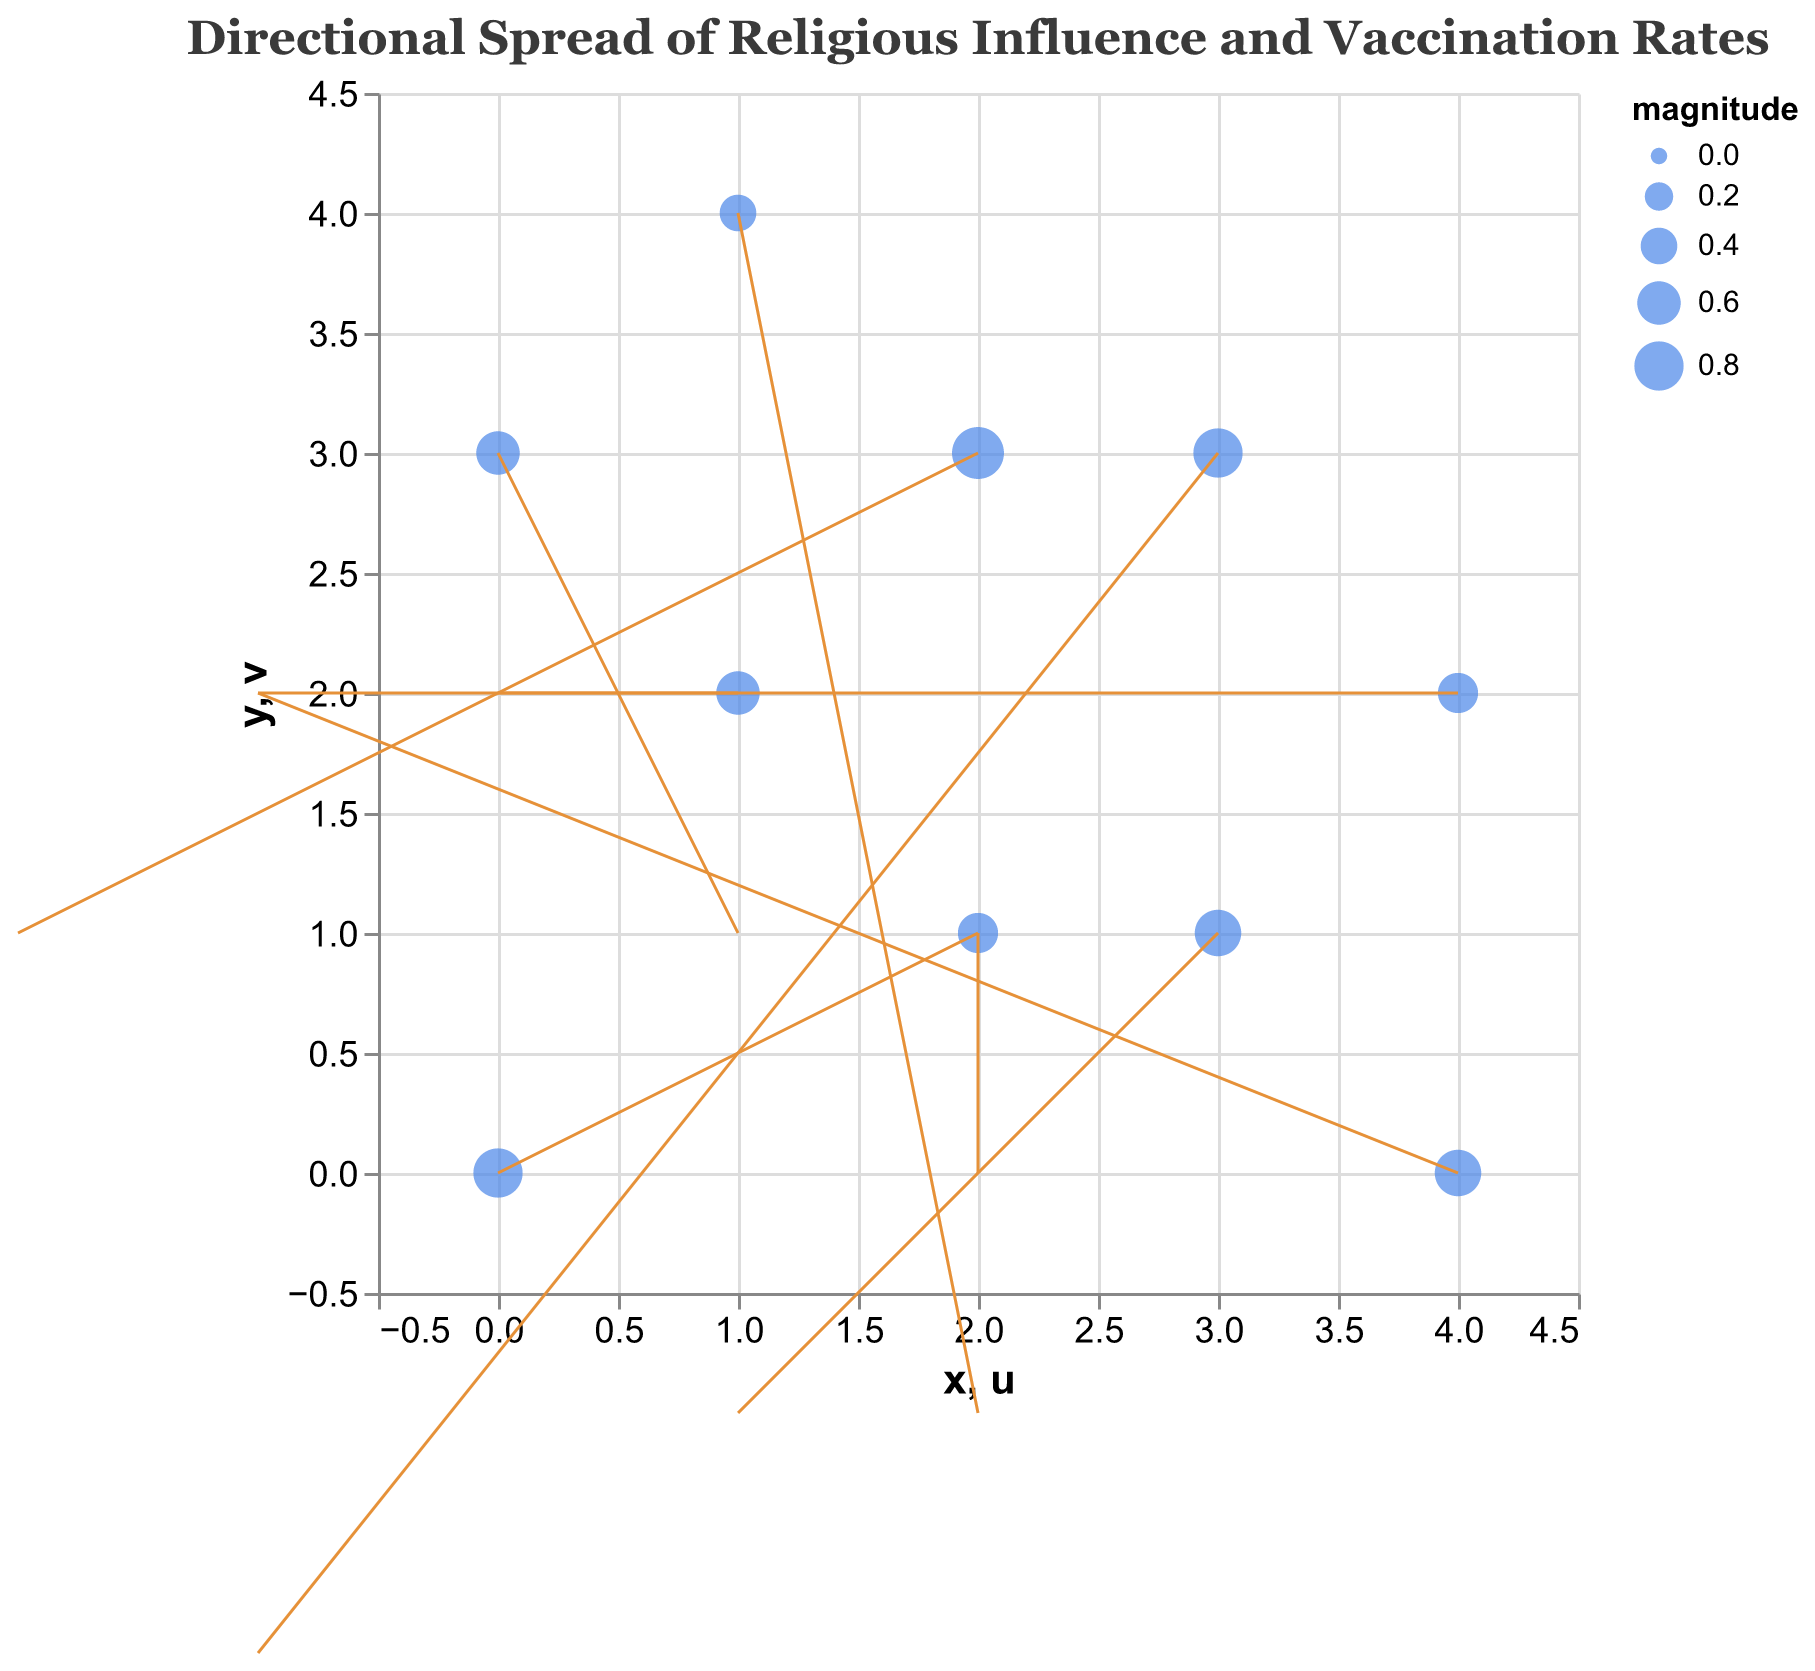What's the title of the figure? The title is usually present at the top of the figure. Here, it is specified explicitly in the data.
Answer: Directional Spread of Religious Influence and Vaccination Rates How many data points are represented in the figure? The figure data contains `x`, `y`, `u`, `v`, and `magnitude` for 10 points. Each of these is a single data point in the quiver plot.
Answer: 10 Which point has the highest magnitude and what is that magnitude? By examining the column of magnitudes, the highest value is at the point (2, 3) with a value of 0.9.
Answer: (2, 3) with a magnitude of 0.9 What is the direction of the point at coordinates (1, 2)? The direction of the point at (1, 2) is given by the `u` and `v` values which are -1 and 2 respectively, indicating a leftward and upward direction.
Answer: Leftward and upward Which point has the vector with the largest horizontal component (u)? A horizontal component is determined by the largest absolute `u` value. The largest absolute value of `u` is 2, which occurs at the points (0, 0), (2, 1), and (1, 4).
Answer: (0, 0), (2, 1), and (1, 4) How many points have a positive vertical component (v)? By counting the positive `v` values, we find those values at the points (0, 0), (1, 2), (2, 3), (4, 2), (0, 3), and (4, 0), making a total of six points.
Answer: 6 Which point(s) exhibit a downward movement? Downward movement is indicated by a negative `v` value. Points (3, 1), (1, 4), and (3, 3) have `v` values of -1, -1, and -2, respectively.
Answer: (3, 1), (1, 4), and (3, 3) What is the average magnitude of the points? Sum the magnitudes: 0.8 + 0.6 + 0.7 + 0.9 + 0.5 + 0.4 + 0.8 + 0.6 + 0.7 + 0.5 = 6.5 and divide by the number of points 10.
Answer: 0.65 Among the points that move upward, which has the smallest magnitude? From the points with positive `v` values: (0, 0) - 0.8, (1, 2) - 0.6, (2, 3) - 0.9, (4, 2) - 0.5, (0, 3) - 0.6, (4, 0) - 0.7, the smallest value is 0.5 at point (4, 2).
Answer: (4, 2) with a magnitude of 0.5 Which point shows a vector that only moves vertically (i.e., no horizontal movement)? Vertical movement is indicated by `u` equal to 0. In the dataset, this occurs at point (4, 2).
Answer: (4, 2) 